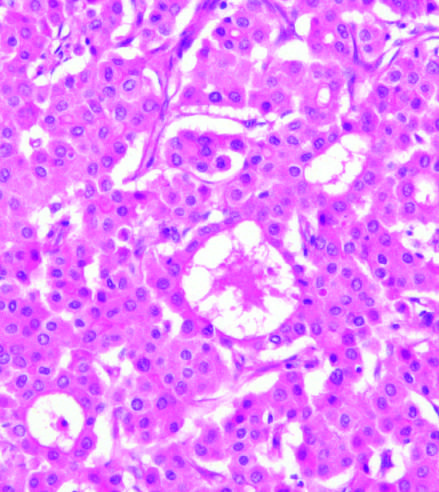did the polypoid areas grow in distorted versions of normal architecture : large pseudoacinar spaces, essentially malformed, dilated bile canaliculi?
Answer the question using a single word or phrase. No 